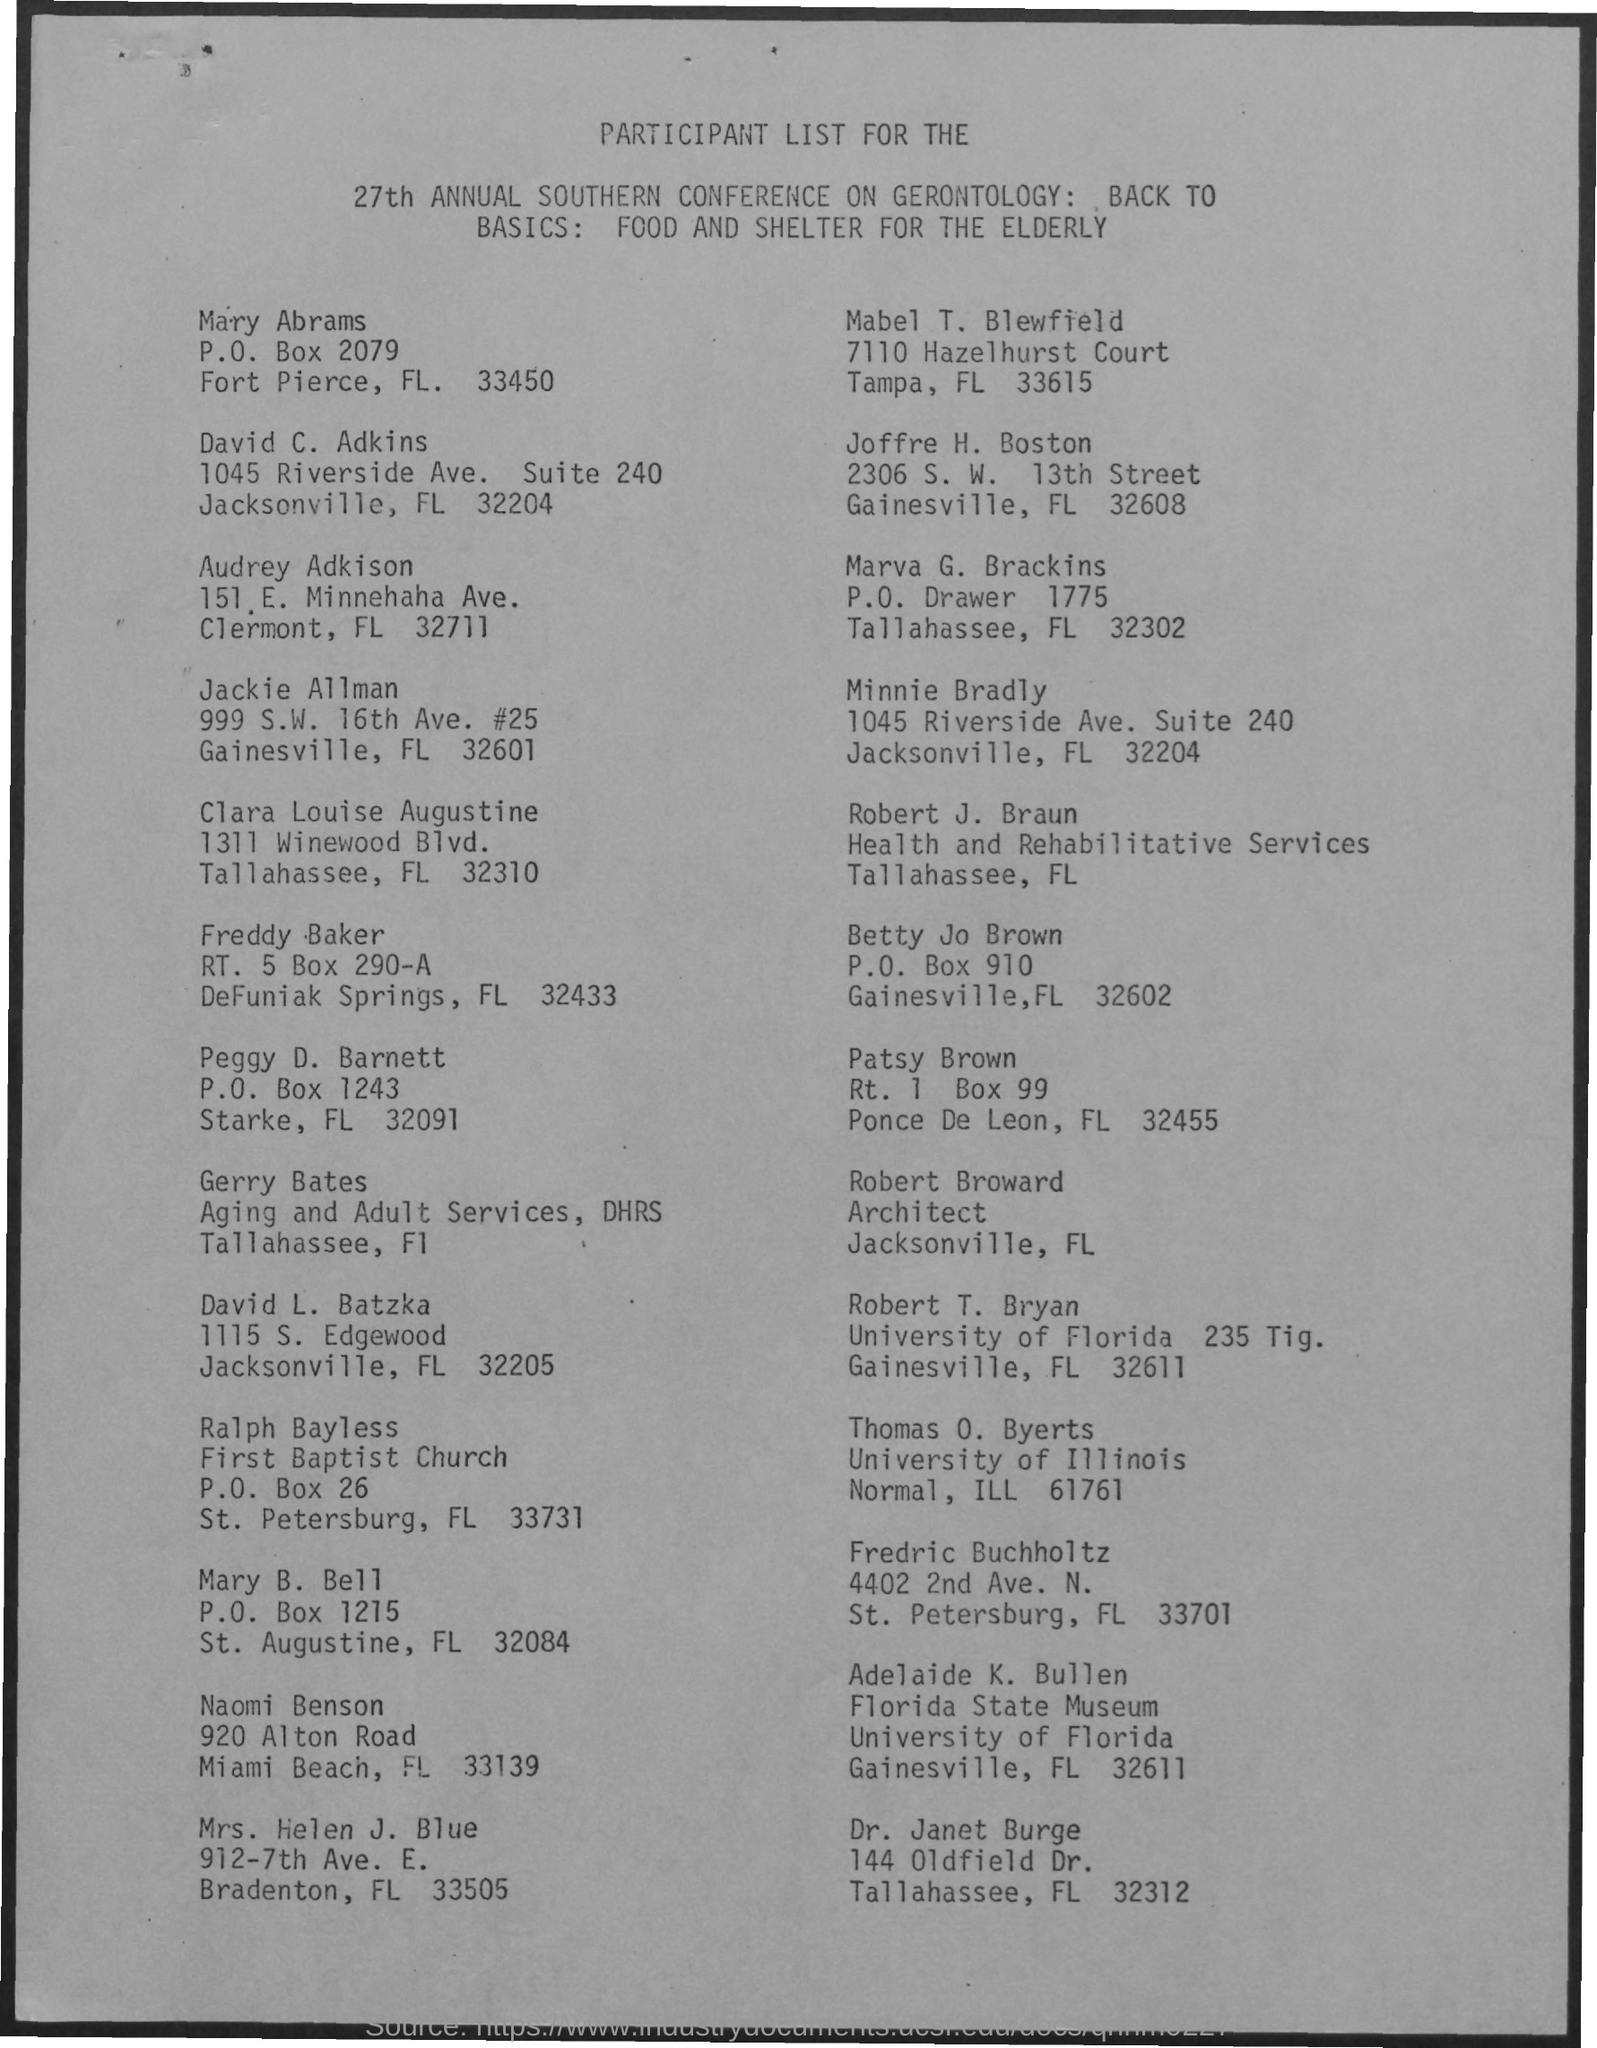Give some essential details in this illustration. Robert Broward's designation is that of an architect. 